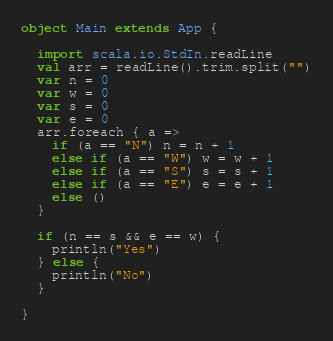Convert code to text. <code><loc_0><loc_0><loc_500><loc_500><_Scala_>object Main extends App {

  import scala.io.StdIn.readLine
  val arr = readLine().trim.split("")
  var n = 0
  var w = 0
  var s = 0
  var e = 0
  arr.foreach { a =>
    if (a == "N") n = n + 1
    else if (a == "W") w = w + 1
    else if (a == "S") s = s + 1
    else if (a == "E") e = e + 1
    else ()
  }

  if (n == s && e == w) {
    println("Yes")
  } else {
    println("No")
  }

}
</code> 